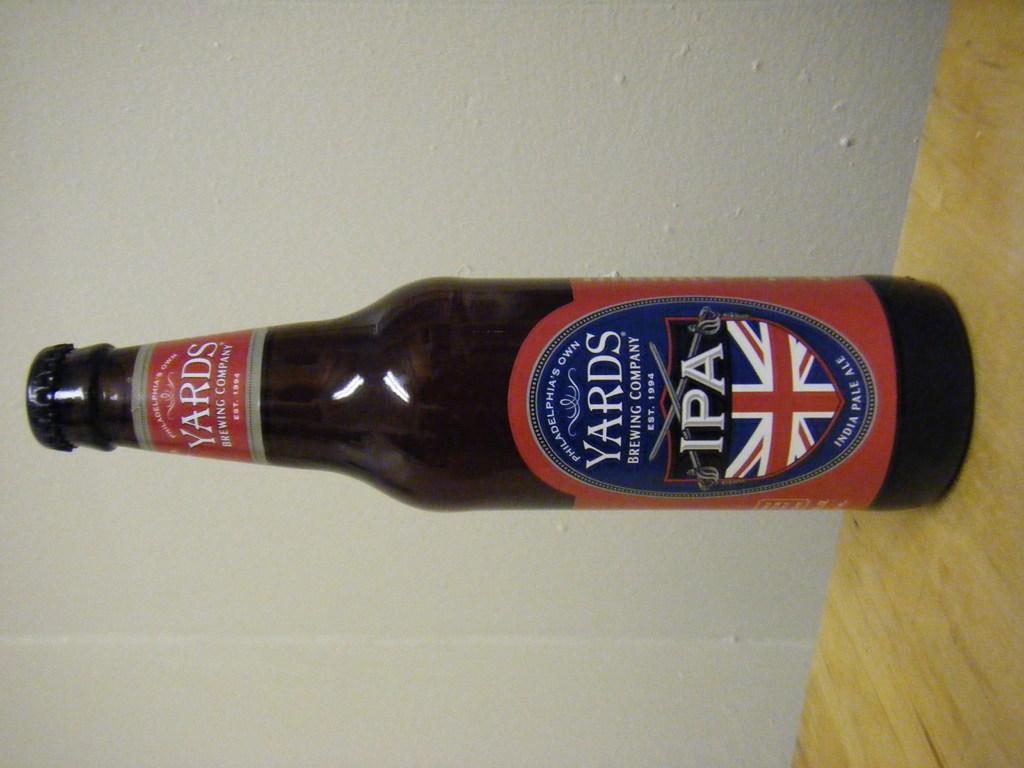Who brews this beer?
Your response must be concise. Yards brewing company. 